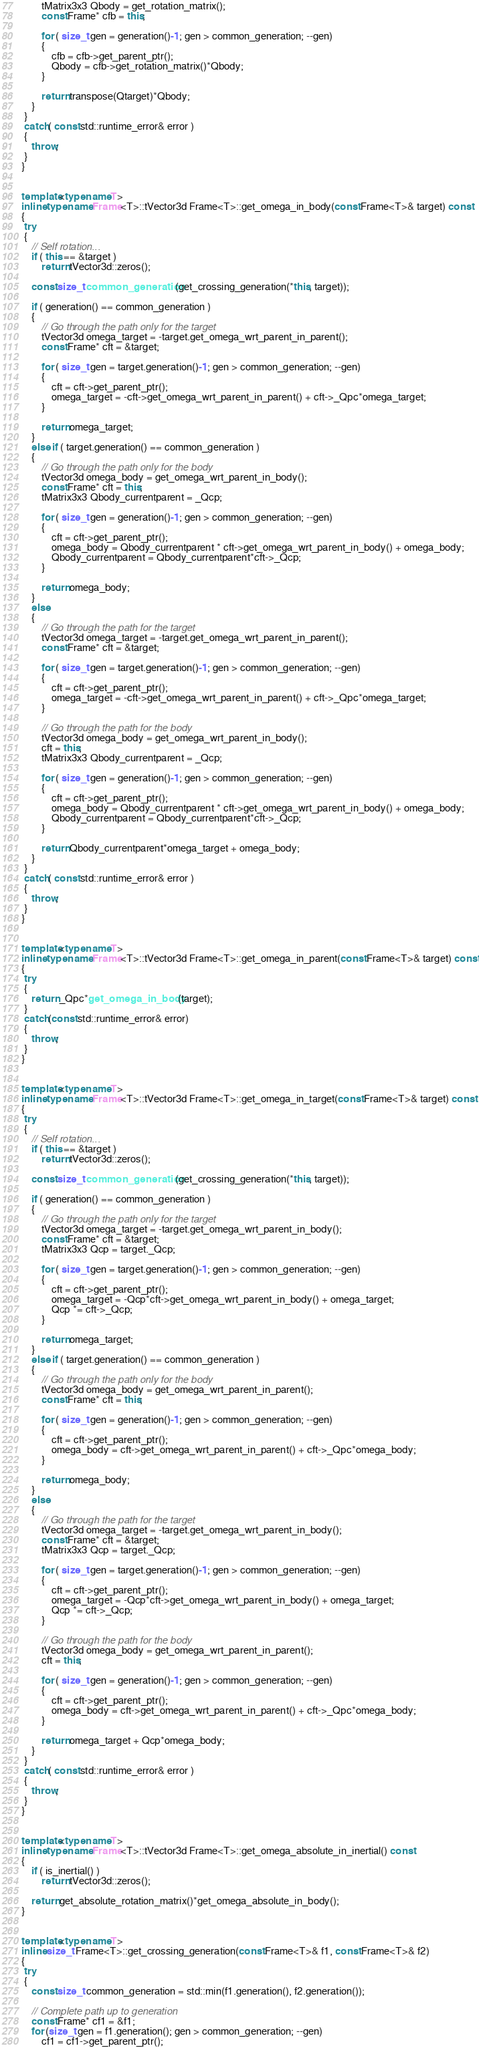<code> <loc_0><loc_0><loc_500><loc_500><_C++_>
        tMatrix3x3 Qbody = get_rotation_matrix();
        const Frame* cfb = this;

        for ( size_t gen = generation()-1; gen > common_generation; --gen)
        {
            cfb = cfb->get_parent_ptr();
            Qbody = cfb->get_rotation_matrix()*Qbody;
        }

        return transpose(Qtarget)*Qbody;
    }
 }
 catch( const std::runtime_error& error )
 {
    throw;
 }
}


template<typename T>
inline typename Frame<T>::tVector3d Frame<T>::get_omega_in_body(const Frame<T>& target) const
{
 try
 {
    // Self rotation...
    if ( this == &target ) 
        return tVector3d::zeros();

    const size_t common_generation(get_crossing_generation(*this, target));

    if ( generation() == common_generation ) 
    {
        // Go through the path only for the target
        tVector3d omega_target = -target.get_omega_wrt_parent_in_parent();
        const Frame* cft = &target;

        for ( size_t gen = target.generation()-1; gen > common_generation; --gen)
        {
            cft = cft->get_parent_ptr();
            omega_target = -cft->get_omega_wrt_parent_in_parent() + cft->_Qpc*omega_target;
        }

        return omega_target;
    }
    else if ( target.generation() == common_generation )
    {
        // Go through the path only for the body
        tVector3d omega_body = get_omega_wrt_parent_in_body();
        const Frame* cft = this;
        tMatrix3x3 Qbody_currentparent = _Qcp;

        for ( size_t gen = generation()-1; gen > common_generation; --gen)
        {
            cft = cft->get_parent_ptr();
            omega_body = Qbody_currentparent * cft->get_omega_wrt_parent_in_body() + omega_body;
            Qbody_currentparent = Qbody_currentparent*cft->_Qcp;
        }

        return omega_body;
    }
    else
    {
        // Go through the path for the target
        tVector3d omega_target = -target.get_omega_wrt_parent_in_parent();
        const Frame* cft = &target;

        for ( size_t gen = target.generation()-1; gen > common_generation; --gen)
        {
            cft = cft->get_parent_ptr();
            omega_target = -cft->get_omega_wrt_parent_in_parent() + cft->_Qpc*omega_target;
        }

        // Go through the path for the body
        tVector3d omega_body = get_omega_wrt_parent_in_body();
        cft = this;
        tMatrix3x3 Qbody_currentparent = _Qcp;

        for ( size_t gen = generation()-1; gen > common_generation; --gen)
        {
            cft = cft->get_parent_ptr();
            omega_body = Qbody_currentparent * cft->get_omega_wrt_parent_in_body() + omega_body;
            Qbody_currentparent = Qbody_currentparent*cft->_Qcp;
        }

        return Qbody_currentparent*omega_target + omega_body;
    }
 }
 catch( const std::runtime_error& error )
 {
    throw;
 }
}


template<typename T>
inline typename Frame<T>::tVector3d Frame<T>::get_omega_in_parent(const Frame<T>& target) const
{
 try
 {
    return _Qpc*get_omega_in_body(target);
 }
 catch(const std::runtime_error& error)
 { 
    throw;
 }
}


template<typename T>
inline typename Frame<T>::tVector3d Frame<T>::get_omega_in_target(const Frame<T>& target) const
{
 try
 {
    // Self rotation...
    if ( this == &target ) 
        return tVector3d::zeros();

    const size_t common_generation(get_crossing_generation(*this, target));

    if ( generation() == common_generation ) 
    {
        // Go through the path only for the target
        tVector3d omega_target = -target.get_omega_wrt_parent_in_body();
        const Frame* cft = &target;
        tMatrix3x3 Qcp = target._Qcp;
    
        for ( size_t gen = target.generation()-1; gen > common_generation; --gen)
        {
            cft = cft->get_parent_ptr();
            omega_target = -Qcp*cft->get_omega_wrt_parent_in_body() + omega_target;
            Qcp *= cft->_Qcp;
        }

        return omega_target;
    }
    else if ( target.generation() == common_generation )
    {
        // Go through the path only for the body
        tVector3d omega_body = get_omega_wrt_parent_in_parent();
        const Frame* cft = this;

        for ( size_t gen = generation()-1; gen > common_generation; --gen)
        {
            cft = cft->get_parent_ptr();
            omega_body = cft->get_omega_wrt_parent_in_parent() + cft->_Qpc*omega_body;
        }

        return omega_body;
    }
    else
    {
        // Go through the path for the target
        tVector3d omega_target = -target.get_omega_wrt_parent_in_body();
        const Frame* cft = &target;
        tMatrix3x3 Qcp = target._Qcp;
    
        for ( size_t gen = target.generation()-1; gen > common_generation; --gen)
        {
            cft = cft->get_parent_ptr();
            omega_target = -Qcp*cft->get_omega_wrt_parent_in_body() + omega_target;
            Qcp *= cft->_Qcp;
        }

        // Go through the path for the body
        tVector3d omega_body = get_omega_wrt_parent_in_parent();
        cft = this;

        for ( size_t gen = generation()-1; gen > common_generation; --gen)
        {
            cft = cft->get_parent_ptr();
            omega_body = cft->get_omega_wrt_parent_in_parent() + cft->_Qpc*omega_body;
        }

        return omega_target + Qcp*omega_body;
    }
 }
 catch( const std::runtime_error& error )
 {
    throw;
 }
}


template<typename T>
inline typename Frame<T>::tVector3d Frame<T>::get_omega_absolute_in_inertial() const
{
    if ( is_inertial() )
        return tVector3d::zeros();

    return get_absolute_rotation_matrix()*get_omega_absolute_in_body();
}


template<typename T>
inline size_t Frame<T>::get_crossing_generation(const Frame<T>& f1, const Frame<T>& f2)
{
 try
 {
    const size_t common_generation = std::min(f1.generation(), f2.generation());

    // Complete path up to generation
    const Frame* cf1 = &f1;
    for (size_t gen = f1.generation(); gen > common_generation; --gen)
        cf1 = cf1->get_parent_ptr();
</code> 